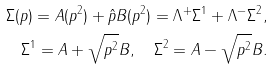<formula> <loc_0><loc_0><loc_500><loc_500>\Sigma ( p ) = A ( p ^ { 2 } ) + \hat { p } B ( p ^ { 2 } ) = \Lambda ^ { + } \Sigma ^ { 1 } + \Lambda ^ { - } \Sigma ^ { 2 } , \\ \Sigma ^ { 1 } = A + \sqrt { p ^ { 2 } } B , \quad \Sigma ^ { 2 } = A - \sqrt { p ^ { 2 } } B .</formula> 